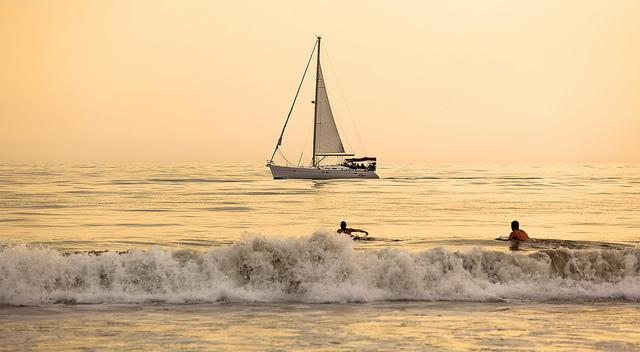What natural feature do the surfers like but the sailors of the boat here hate? waves 